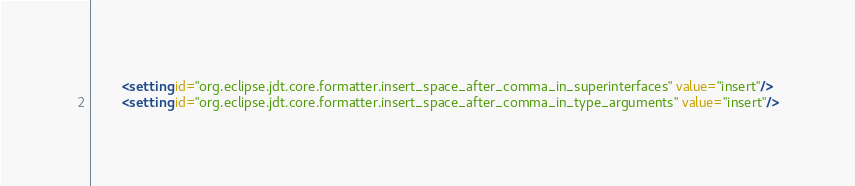<code> <loc_0><loc_0><loc_500><loc_500><_XML_>        <setting id="org.eclipse.jdt.core.formatter.insert_space_after_comma_in_superinterfaces" value="insert"/>
        <setting id="org.eclipse.jdt.core.formatter.insert_space_after_comma_in_type_arguments" value="insert"/></code> 